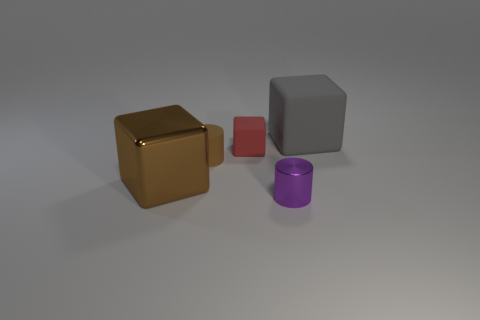Add 1 brown shiny things. How many objects exist? 6 Subtract all purple cylinders. How many cylinders are left? 1 Subtract all gray cubes. How many cubes are left? 2 Subtract 0 cyan cubes. How many objects are left? 5 Subtract all cubes. How many objects are left? 2 Subtract 1 cubes. How many cubes are left? 2 Subtract all brown blocks. Subtract all yellow cylinders. How many blocks are left? 2 Subtract all blue balls. How many red cubes are left? 1 Subtract all red rubber objects. Subtract all large gray matte blocks. How many objects are left? 3 Add 2 gray objects. How many gray objects are left? 3 